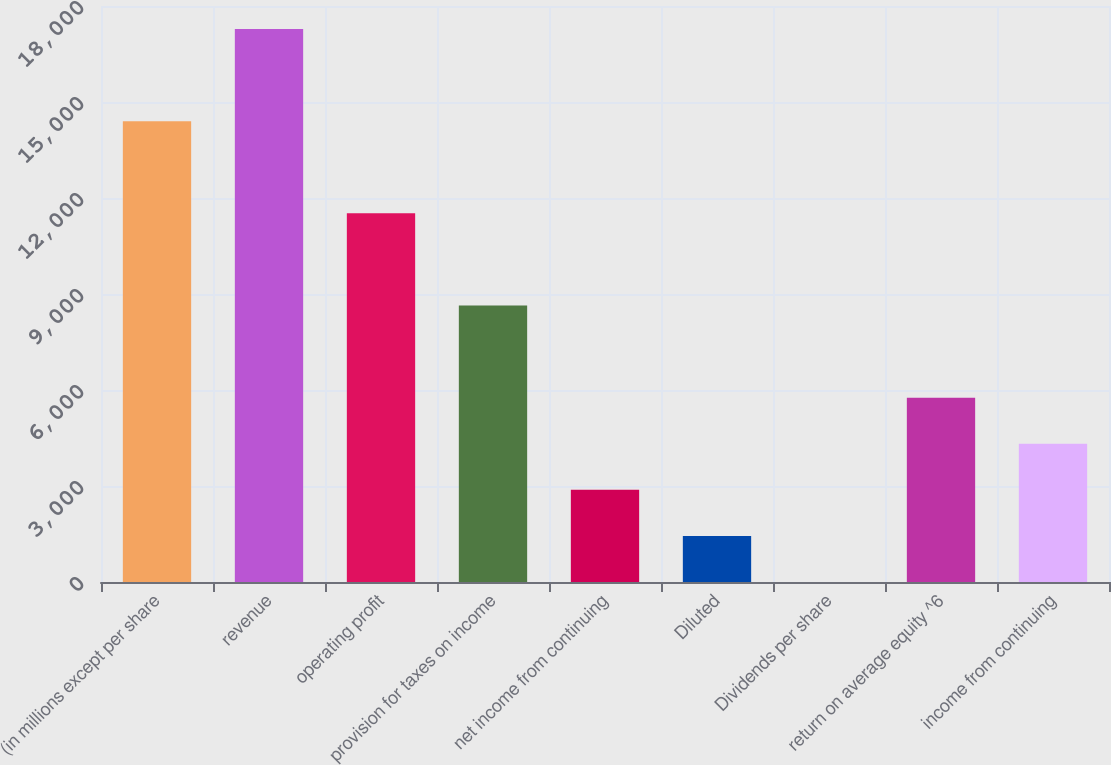Convert chart to OTSL. <chart><loc_0><loc_0><loc_500><loc_500><bar_chart><fcel>(in millions except per share<fcel>revenue<fcel>operating profit<fcel>provision for taxes on income<fcel>net income from continuing<fcel>Diluted<fcel>Dividends per share<fcel>return on average equity ^6<fcel>income from continuing<nl><fcel>14400<fcel>17279.9<fcel>11520.2<fcel>8640.4<fcel>2880.76<fcel>1440.85<fcel>0.94<fcel>5760.58<fcel>4320.67<nl></chart> 